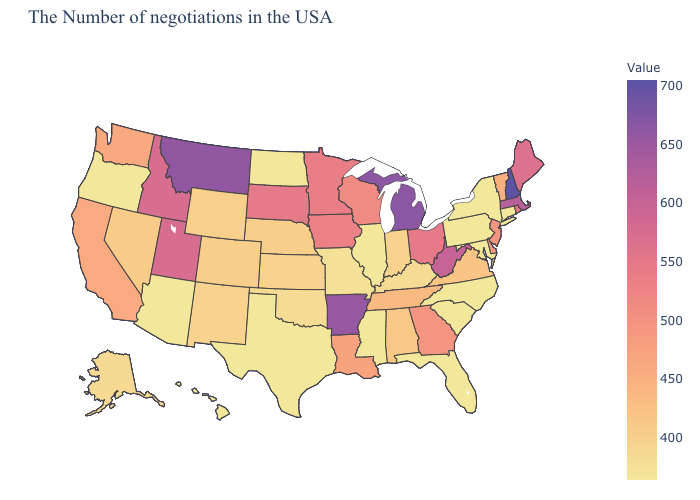Does Wisconsin have a higher value than Oklahoma?
Be succinct. Yes. Which states hav the highest value in the Northeast?
Give a very brief answer. New Hampshire. Which states hav the highest value in the MidWest?
Quick response, please. Michigan. Does Michigan have the highest value in the MidWest?
Concise answer only. Yes. Among the states that border Georgia , does South Carolina have the lowest value?
Short answer required. Yes. Which states have the lowest value in the West?
Write a very short answer. Arizona, Oregon, Hawaii. 